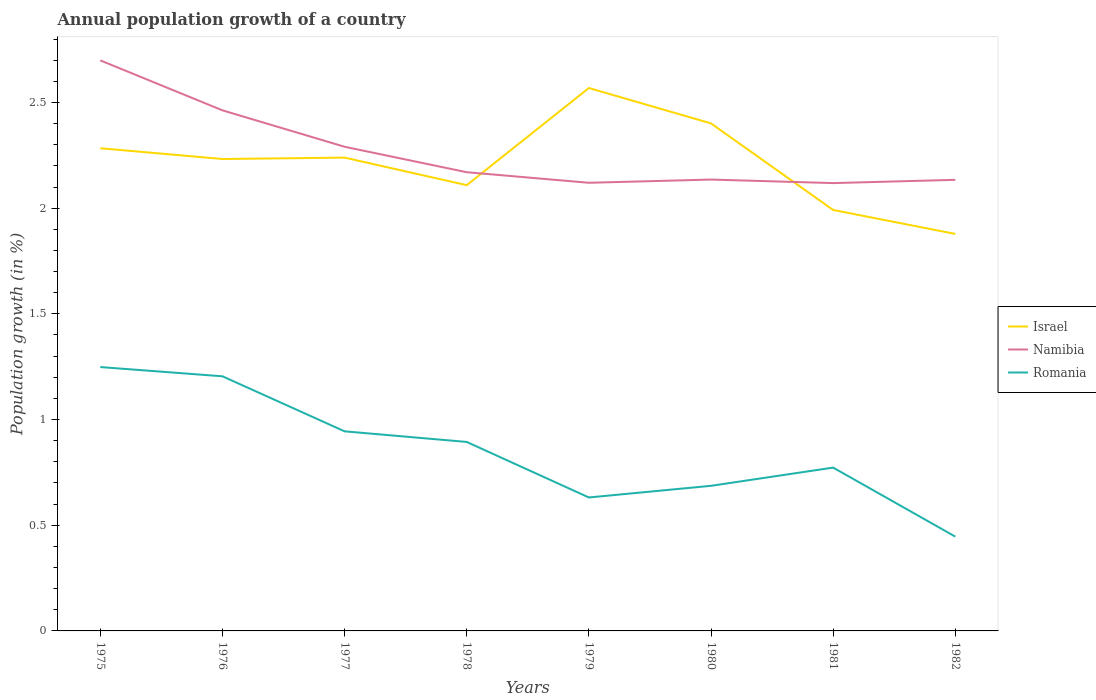Across all years, what is the maximum annual population growth in Namibia?
Your response must be concise. 2.12. What is the total annual population growth in Romania in the graph?
Offer a very short reply. 0.19. What is the difference between the highest and the second highest annual population growth in Israel?
Provide a short and direct response. 0.69. What is the difference between the highest and the lowest annual population growth in Israel?
Provide a succinct answer. 5. Is the annual population growth in Namibia strictly greater than the annual population growth in Romania over the years?
Make the answer very short. No. How many years are there in the graph?
Provide a succinct answer. 8. What is the difference between two consecutive major ticks on the Y-axis?
Keep it short and to the point. 0.5. Does the graph contain any zero values?
Ensure brevity in your answer.  No. Does the graph contain grids?
Keep it short and to the point. No. Where does the legend appear in the graph?
Your answer should be very brief. Center right. How many legend labels are there?
Your response must be concise. 3. What is the title of the graph?
Your answer should be very brief. Annual population growth of a country. What is the label or title of the Y-axis?
Make the answer very short. Population growth (in %). What is the Population growth (in %) in Israel in 1975?
Your answer should be compact. 2.28. What is the Population growth (in %) in Namibia in 1975?
Give a very brief answer. 2.7. What is the Population growth (in %) of Romania in 1975?
Offer a very short reply. 1.25. What is the Population growth (in %) of Israel in 1976?
Your answer should be very brief. 2.23. What is the Population growth (in %) of Namibia in 1976?
Provide a short and direct response. 2.46. What is the Population growth (in %) in Romania in 1976?
Your answer should be very brief. 1.2. What is the Population growth (in %) in Israel in 1977?
Keep it short and to the point. 2.24. What is the Population growth (in %) of Namibia in 1977?
Offer a very short reply. 2.29. What is the Population growth (in %) in Romania in 1977?
Make the answer very short. 0.94. What is the Population growth (in %) of Israel in 1978?
Your answer should be compact. 2.11. What is the Population growth (in %) of Namibia in 1978?
Ensure brevity in your answer.  2.17. What is the Population growth (in %) in Romania in 1978?
Give a very brief answer. 0.89. What is the Population growth (in %) in Israel in 1979?
Give a very brief answer. 2.57. What is the Population growth (in %) in Namibia in 1979?
Ensure brevity in your answer.  2.12. What is the Population growth (in %) in Romania in 1979?
Offer a very short reply. 0.63. What is the Population growth (in %) in Israel in 1980?
Your answer should be very brief. 2.4. What is the Population growth (in %) in Namibia in 1980?
Provide a short and direct response. 2.14. What is the Population growth (in %) in Romania in 1980?
Offer a very short reply. 0.69. What is the Population growth (in %) of Israel in 1981?
Ensure brevity in your answer.  1.99. What is the Population growth (in %) in Namibia in 1981?
Your answer should be very brief. 2.12. What is the Population growth (in %) in Romania in 1981?
Offer a terse response. 0.77. What is the Population growth (in %) of Israel in 1982?
Your answer should be very brief. 1.88. What is the Population growth (in %) in Namibia in 1982?
Offer a terse response. 2.13. What is the Population growth (in %) of Romania in 1982?
Offer a terse response. 0.45. Across all years, what is the maximum Population growth (in %) in Israel?
Your answer should be very brief. 2.57. Across all years, what is the maximum Population growth (in %) in Namibia?
Keep it short and to the point. 2.7. Across all years, what is the maximum Population growth (in %) of Romania?
Offer a very short reply. 1.25. Across all years, what is the minimum Population growth (in %) in Israel?
Your answer should be very brief. 1.88. Across all years, what is the minimum Population growth (in %) of Namibia?
Your answer should be compact. 2.12. Across all years, what is the minimum Population growth (in %) of Romania?
Offer a terse response. 0.45. What is the total Population growth (in %) of Israel in the graph?
Ensure brevity in your answer.  17.7. What is the total Population growth (in %) in Namibia in the graph?
Ensure brevity in your answer.  18.13. What is the total Population growth (in %) of Romania in the graph?
Give a very brief answer. 6.83. What is the difference between the Population growth (in %) in Israel in 1975 and that in 1976?
Make the answer very short. 0.05. What is the difference between the Population growth (in %) of Namibia in 1975 and that in 1976?
Provide a succinct answer. 0.24. What is the difference between the Population growth (in %) in Romania in 1975 and that in 1976?
Your answer should be compact. 0.04. What is the difference between the Population growth (in %) in Israel in 1975 and that in 1977?
Your answer should be very brief. 0.04. What is the difference between the Population growth (in %) in Namibia in 1975 and that in 1977?
Provide a succinct answer. 0.41. What is the difference between the Population growth (in %) of Romania in 1975 and that in 1977?
Your response must be concise. 0.3. What is the difference between the Population growth (in %) of Israel in 1975 and that in 1978?
Provide a succinct answer. 0.17. What is the difference between the Population growth (in %) of Namibia in 1975 and that in 1978?
Your answer should be very brief. 0.53. What is the difference between the Population growth (in %) of Romania in 1975 and that in 1978?
Your answer should be compact. 0.35. What is the difference between the Population growth (in %) in Israel in 1975 and that in 1979?
Keep it short and to the point. -0.28. What is the difference between the Population growth (in %) in Namibia in 1975 and that in 1979?
Offer a terse response. 0.58. What is the difference between the Population growth (in %) in Romania in 1975 and that in 1979?
Ensure brevity in your answer.  0.62. What is the difference between the Population growth (in %) of Israel in 1975 and that in 1980?
Your answer should be compact. -0.12. What is the difference between the Population growth (in %) of Namibia in 1975 and that in 1980?
Your answer should be compact. 0.56. What is the difference between the Population growth (in %) of Romania in 1975 and that in 1980?
Provide a succinct answer. 0.56. What is the difference between the Population growth (in %) in Israel in 1975 and that in 1981?
Give a very brief answer. 0.29. What is the difference between the Population growth (in %) in Namibia in 1975 and that in 1981?
Your answer should be compact. 0.58. What is the difference between the Population growth (in %) in Romania in 1975 and that in 1981?
Offer a terse response. 0.48. What is the difference between the Population growth (in %) of Israel in 1975 and that in 1982?
Make the answer very short. 0.41. What is the difference between the Population growth (in %) in Namibia in 1975 and that in 1982?
Provide a succinct answer. 0.57. What is the difference between the Population growth (in %) of Romania in 1975 and that in 1982?
Ensure brevity in your answer.  0.8. What is the difference between the Population growth (in %) of Israel in 1976 and that in 1977?
Your answer should be compact. -0.01. What is the difference between the Population growth (in %) in Namibia in 1976 and that in 1977?
Keep it short and to the point. 0.17. What is the difference between the Population growth (in %) in Romania in 1976 and that in 1977?
Provide a succinct answer. 0.26. What is the difference between the Population growth (in %) of Israel in 1976 and that in 1978?
Offer a terse response. 0.12. What is the difference between the Population growth (in %) of Namibia in 1976 and that in 1978?
Provide a short and direct response. 0.29. What is the difference between the Population growth (in %) in Romania in 1976 and that in 1978?
Provide a short and direct response. 0.31. What is the difference between the Population growth (in %) of Israel in 1976 and that in 1979?
Offer a very short reply. -0.34. What is the difference between the Population growth (in %) of Namibia in 1976 and that in 1979?
Keep it short and to the point. 0.34. What is the difference between the Population growth (in %) of Romania in 1976 and that in 1979?
Make the answer very short. 0.57. What is the difference between the Population growth (in %) in Israel in 1976 and that in 1980?
Make the answer very short. -0.17. What is the difference between the Population growth (in %) in Namibia in 1976 and that in 1980?
Give a very brief answer. 0.33. What is the difference between the Population growth (in %) of Romania in 1976 and that in 1980?
Your answer should be very brief. 0.52. What is the difference between the Population growth (in %) in Israel in 1976 and that in 1981?
Offer a very short reply. 0.24. What is the difference between the Population growth (in %) in Namibia in 1976 and that in 1981?
Your response must be concise. 0.34. What is the difference between the Population growth (in %) of Romania in 1976 and that in 1981?
Ensure brevity in your answer.  0.43. What is the difference between the Population growth (in %) in Israel in 1976 and that in 1982?
Make the answer very short. 0.35. What is the difference between the Population growth (in %) in Namibia in 1976 and that in 1982?
Your response must be concise. 0.33. What is the difference between the Population growth (in %) of Romania in 1976 and that in 1982?
Your answer should be very brief. 0.76. What is the difference between the Population growth (in %) in Israel in 1977 and that in 1978?
Provide a short and direct response. 0.13. What is the difference between the Population growth (in %) in Namibia in 1977 and that in 1978?
Offer a very short reply. 0.12. What is the difference between the Population growth (in %) in Romania in 1977 and that in 1978?
Keep it short and to the point. 0.05. What is the difference between the Population growth (in %) of Israel in 1977 and that in 1979?
Provide a succinct answer. -0.33. What is the difference between the Population growth (in %) in Namibia in 1977 and that in 1979?
Your answer should be very brief. 0.17. What is the difference between the Population growth (in %) of Romania in 1977 and that in 1979?
Provide a short and direct response. 0.31. What is the difference between the Population growth (in %) of Israel in 1977 and that in 1980?
Your answer should be compact. -0.16. What is the difference between the Population growth (in %) in Namibia in 1977 and that in 1980?
Give a very brief answer. 0.16. What is the difference between the Population growth (in %) in Romania in 1977 and that in 1980?
Provide a succinct answer. 0.26. What is the difference between the Population growth (in %) in Israel in 1977 and that in 1981?
Ensure brevity in your answer.  0.25. What is the difference between the Population growth (in %) in Namibia in 1977 and that in 1981?
Offer a terse response. 0.17. What is the difference between the Population growth (in %) of Romania in 1977 and that in 1981?
Offer a very short reply. 0.17. What is the difference between the Population growth (in %) in Israel in 1977 and that in 1982?
Offer a terse response. 0.36. What is the difference between the Population growth (in %) of Namibia in 1977 and that in 1982?
Provide a succinct answer. 0.16. What is the difference between the Population growth (in %) of Romania in 1977 and that in 1982?
Your answer should be compact. 0.5. What is the difference between the Population growth (in %) of Israel in 1978 and that in 1979?
Give a very brief answer. -0.46. What is the difference between the Population growth (in %) of Romania in 1978 and that in 1979?
Provide a succinct answer. 0.26. What is the difference between the Population growth (in %) in Israel in 1978 and that in 1980?
Provide a short and direct response. -0.29. What is the difference between the Population growth (in %) in Namibia in 1978 and that in 1980?
Offer a terse response. 0.03. What is the difference between the Population growth (in %) in Romania in 1978 and that in 1980?
Your answer should be compact. 0.21. What is the difference between the Population growth (in %) in Israel in 1978 and that in 1981?
Your answer should be compact. 0.12. What is the difference between the Population growth (in %) of Namibia in 1978 and that in 1981?
Give a very brief answer. 0.05. What is the difference between the Population growth (in %) of Romania in 1978 and that in 1981?
Your response must be concise. 0.12. What is the difference between the Population growth (in %) in Israel in 1978 and that in 1982?
Make the answer very short. 0.23. What is the difference between the Population growth (in %) in Namibia in 1978 and that in 1982?
Your response must be concise. 0.04. What is the difference between the Population growth (in %) in Romania in 1978 and that in 1982?
Provide a succinct answer. 0.45. What is the difference between the Population growth (in %) in Israel in 1979 and that in 1980?
Keep it short and to the point. 0.17. What is the difference between the Population growth (in %) in Namibia in 1979 and that in 1980?
Provide a short and direct response. -0.02. What is the difference between the Population growth (in %) in Romania in 1979 and that in 1980?
Make the answer very short. -0.06. What is the difference between the Population growth (in %) in Israel in 1979 and that in 1981?
Provide a short and direct response. 0.58. What is the difference between the Population growth (in %) of Namibia in 1979 and that in 1981?
Your answer should be very brief. 0. What is the difference between the Population growth (in %) of Romania in 1979 and that in 1981?
Make the answer very short. -0.14. What is the difference between the Population growth (in %) in Israel in 1979 and that in 1982?
Provide a short and direct response. 0.69. What is the difference between the Population growth (in %) of Namibia in 1979 and that in 1982?
Your answer should be very brief. -0.01. What is the difference between the Population growth (in %) of Romania in 1979 and that in 1982?
Offer a very short reply. 0.19. What is the difference between the Population growth (in %) in Israel in 1980 and that in 1981?
Offer a very short reply. 0.41. What is the difference between the Population growth (in %) in Namibia in 1980 and that in 1981?
Your answer should be compact. 0.02. What is the difference between the Population growth (in %) in Romania in 1980 and that in 1981?
Your response must be concise. -0.09. What is the difference between the Population growth (in %) of Israel in 1980 and that in 1982?
Provide a short and direct response. 0.52. What is the difference between the Population growth (in %) of Namibia in 1980 and that in 1982?
Provide a succinct answer. 0. What is the difference between the Population growth (in %) of Romania in 1980 and that in 1982?
Give a very brief answer. 0.24. What is the difference between the Population growth (in %) in Israel in 1981 and that in 1982?
Provide a short and direct response. 0.11. What is the difference between the Population growth (in %) in Namibia in 1981 and that in 1982?
Provide a succinct answer. -0.02. What is the difference between the Population growth (in %) in Romania in 1981 and that in 1982?
Provide a succinct answer. 0.33. What is the difference between the Population growth (in %) of Israel in 1975 and the Population growth (in %) of Namibia in 1976?
Offer a terse response. -0.18. What is the difference between the Population growth (in %) in Israel in 1975 and the Population growth (in %) in Romania in 1976?
Keep it short and to the point. 1.08. What is the difference between the Population growth (in %) of Namibia in 1975 and the Population growth (in %) of Romania in 1976?
Provide a short and direct response. 1.49. What is the difference between the Population growth (in %) of Israel in 1975 and the Population growth (in %) of Namibia in 1977?
Your response must be concise. -0.01. What is the difference between the Population growth (in %) in Israel in 1975 and the Population growth (in %) in Romania in 1977?
Offer a terse response. 1.34. What is the difference between the Population growth (in %) of Namibia in 1975 and the Population growth (in %) of Romania in 1977?
Your answer should be very brief. 1.75. What is the difference between the Population growth (in %) of Israel in 1975 and the Population growth (in %) of Namibia in 1978?
Offer a very short reply. 0.11. What is the difference between the Population growth (in %) in Israel in 1975 and the Population growth (in %) in Romania in 1978?
Give a very brief answer. 1.39. What is the difference between the Population growth (in %) in Namibia in 1975 and the Population growth (in %) in Romania in 1978?
Ensure brevity in your answer.  1.81. What is the difference between the Population growth (in %) of Israel in 1975 and the Population growth (in %) of Namibia in 1979?
Make the answer very short. 0.16. What is the difference between the Population growth (in %) in Israel in 1975 and the Population growth (in %) in Romania in 1979?
Your answer should be compact. 1.65. What is the difference between the Population growth (in %) in Namibia in 1975 and the Population growth (in %) in Romania in 1979?
Keep it short and to the point. 2.07. What is the difference between the Population growth (in %) of Israel in 1975 and the Population growth (in %) of Namibia in 1980?
Your answer should be very brief. 0.15. What is the difference between the Population growth (in %) of Israel in 1975 and the Population growth (in %) of Romania in 1980?
Offer a terse response. 1.6. What is the difference between the Population growth (in %) of Namibia in 1975 and the Population growth (in %) of Romania in 1980?
Provide a succinct answer. 2.01. What is the difference between the Population growth (in %) in Israel in 1975 and the Population growth (in %) in Namibia in 1981?
Provide a succinct answer. 0.16. What is the difference between the Population growth (in %) in Israel in 1975 and the Population growth (in %) in Romania in 1981?
Your answer should be very brief. 1.51. What is the difference between the Population growth (in %) of Namibia in 1975 and the Population growth (in %) of Romania in 1981?
Provide a succinct answer. 1.93. What is the difference between the Population growth (in %) in Israel in 1975 and the Population growth (in %) in Namibia in 1982?
Give a very brief answer. 0.15. What is the difference between the Population growth (in %) in Israel in 1975 and the Population growth (in %) in Romania in 1982?
Give a very brief answer. 1.84. What is the difference between the Population growth (in %) of Namibia in 1975 and the Population growth (in %) of Romania in 1982?
Your answer should be very brief. 2.25. What is the difference between the Population growth (in %) of Israel in 1976 and the Population growth (in %) of Namibia in 1977?
Your answer should be compact. -0.06. What is the difference between the Population growth (in %) of Israel in 1976 and the Population growth (in %) of Romania in 1977?
Ensure brevity in your answer.  1.29. What is the difference between the Population growth (in %) of Namibia in 1976 and the Population growth (in %) of Romania in 1977?
Keep it short and to the point. 1.52. What is the difference between the Population growth (in %) of Israel in 1976 and the Population growth (in %) of Namibia in 1978?
Offer a very short reply. 0.06. What is the difference between the Population growth (in %) in Israel in 1976 and the Population growth (in %) in Romania in 1978?
Offer a terse response. 1.34. What is the difference between the Population growth (in %) of Namibia in 1976 and the Population growth (in %) of Romania in 1978?
Your answer should be very brief. 1.57. What is the difference between the Population growth (in %) in Israel in 1976 and the Population growth (in %) in Namibia in 1979?
Keep it short and to the point. 0.11. What is the difference between the Population growth (in %) in Israel in 1976 and the Population growth (in %) in Romania in 1979?
Make the answer very short. 1.6. What is the difference between the Population growth (in %) of Namibia in 1976 and the Population growth (in %) of Romania in 1979?
Your response must be concise. 1.83. What is the difference between the Population growth (in %) in Israel in 1976 and the Population growth (in %) in Namibia in 1980?
Give a very brief answer. 0.1. What is the difference between the Population growth (in %) of Israel in 1976 and the Population growth (in %) of Romania in 1980?
Make the answer very short. 1.55. What is the difference between the Population growth (in %) of Namibia in 1976 and the Population growth (in %) of Romania in 1980?
Make the answer very short. 1.78. What is the difference between the Population growth (in %) of Israel in 1976 and the Population growth (in %) of Namibia in 1981?
Offer a terse response. 0.11. What is the difference between the Population growth (in %) in Israel in 1976 and the Population growth (in %) in Romania in 1981?
Your answer should be very brief. 1.46. What is the difference between the Population growth (in %) of Namibia in 1976 and the Population growth (in %) of Romania in 1981?
Offer a terse response. 1.69. What is the difference between the Population growth (in %) in Israel in 1976 and the Population growth (in %) in Namibia in 1982?
Provide a succinct answer. 0.1. What is the difference between the Population growth (in %) in Israel in 1976 and the Population growth (in %) in Romania in 1982?
Make the answer very short. 1.79. What is the difference between the Population growth (in %) in Namibia in 1976 and the Population growth (in %) in Romania in 1982?
Your answer should be compact. 2.02. What is the difference between the Population growth (in %) of Israel in 1977 and the Population growth (in %) of Namibia in 1978?
Your answer should be compact. 0.07. What is the difference between the Population growth (in %) in Israel in 1977 and the Population growth (in %) in Romania in 1978?
Offer a very short reply. 1.35. What is the difference between the Population growth (in %) in Namibia in 1977 and the Population growth (in %) in Romania in 1978?
Ensure brevity in your answer.  1.4. What is the difference between the Population growth (in %) of Israel in 1977 and the Population growth (in %) of Namibia in 1979?
Make the answer very short. 0.12. What is the difference between the Population growth (in %) of Israel in 1977 and the Population growth (in %) of Romania in 1979?
Offer a very short reply. 1.61. What is the difference between the Population growth (in %) of Namibia in 1977 and the Population growth (in %) of Romania in 1979?
Make the answer very short. 1.66. What is the difference between the Population growth (in %) of Israel in 1977 and the Population growth (in %) of Namibia in 1980?
Provide a short and direct response. 0.1. What is the difference between the Population growth (in %) in Israel in 1977 and the Population growth (in %) in Romania in 1980?
Offer a very short reply. 1.55. What is the difference between the Population growth (in %) of Namibia in 1977 and the Population growth (in %) of Romania in 1980?
Your answer should be compact. 1.6. What is the difference between the Population growth (in %) of Israel in 1977 and the Population growth (in %) of Namibia in 1981?
Your answer should be very brief. 0.12. What is the difference between the Population growth (in %) of Israel in 1977 and the Population growth (in %) of Romania in 1981?
Keep it short and to the point. 1.47. What is the difference between the Population growth (in %) of Namibia in 1977 and the Population growth (in %) of Romania in 1981?
Your response must be concise. 1.52. What is the difference between the Population growth (in %) in Israel in 1977 and the Population growth (in %) in Namibia in 1982?
Your answer should be very brief. 0.11. What is the difference between the Population growth (in %) in Israel in 1977 and the Population growth (in %) in Romania in 1982?
Offer a terse response. 1.79. What is the difference between the Population growth (in %) in Namibia in 1977 and the Population growth (in %) in Romania in 1982?
Keep it short and to the point. 1.84. What is the difference between the Population growth (in %) in Israel in 1978 and the Population growth (in %) in Namibia in 1979?
Make the answer very short. -0.01. What is the difference between the Population growth (in %) of Israel in 1978 and the Population growth (in %) of Romania in 1979?
Provide a short and direct response. 1.48. What is the difference between the Population growth (in %) of Namibia in 1978 and the Population growth (in %) of Romania in 1979?
Ensure brevity in your answer.  1.54. What is the difference between the Population growth (in %) in Israel in 1978 and the Population growth (in %) in Namibia in 1980?
Provide a succinct answer. -0.03. What is the difference between the Population growth (in %) in Israel in 1978 and the Population growth (in %) in Romania in 1980?
Ensure brevity in your answer.  1.42. What is the difference between the Population growth (in %) in Namibia in 1978 and the Population growth (in %) in Romania in 1980?
Make the answer very short. 1.48. What is the difference between the Population growth (in %) in Israel in 1978 and the Population growth (in %) in Namibia in 1981?
Ensure brevity in your answer.  -0.01. What is the difference between the Population growth (in %) in Israel in 1978 and the Population growth (in %) in Romania in 1981?
Make the answer very short. 1.34. What is the difference between the Population growth (in %) in Namibia in 1978 and the Population growth (in %) in Romania in 1981?
Keep it short and to the point. 1.4. What is the difference between the Population growth (in %) in Israel in 1978 and the Population growth (in %) in Namibia in 1982?
Give a very brief answer. -0.03. What is the difference between the Population growth (in %) of Israel in 1978 and the Population growth (in %) of Romania in 1982?
Offer a very short reply. 1.66. What is the difference between the Population growth (in %) in Namibia in 1978 and the Population growth (in %) in Romania in 1982?
Keep it short and to the point. 1.72. What is the difference between the Population growth (in %) in Israel in 1979 and the Population growth (in %) in Namibia in 1980?
Your response must be concise. 0.43. What is the difference between the Population growth (in %) of Israel in 1979 and the Population growth (in %) of Romania in 1980?
Make the answer very short. 1.88. What is the difference between the Population growth (in %) of Namibia in 1979 and the Population growth (in %) of Romania in 1980?
Offer a terse response. 1.43. What is the difference between the Population growth (in %) of Israel in 1979 and the Population growth (in %) of Namibia in 1981?
Offer a terse response. 0.45. What is the difference between the Population growth (in %) of Israel in 1979 and the Population growth (in %) of Romania in 1981?
Keep it short and to the point. 1.8. What is the difference between the Population growth (in %) in Namibia in 1979 and the Population growth (in %) in Romania in 1981?
Your answer should be very brief. 1.35. What is the difference between the Population growth (in %) of Israel in 1979 and the Population growth (in %) of Namibia in 1982?
Ensure brevity in your answer.  0.43. What is the difference between the Population growth (in %) in Israel in 1979 and the Population growth (in %) in Romania in 1982?
Offer a terse response. 2.12. What is the difference between the Population growth (in %) in Namibia in 1979 and the Population growth (in %) in Romania in 1982?
Give a very brief answer. 1.67. What is the difference between the Population growth (in %) in Israel in 1980 and the Population growth (in %) in Namibia in 1981?
Your response must be concise. 0.28. What is the difference between the Population growth (in %) in Israel in 1980 and the Population growth (in %) in Romania in 1981?
Provide a short and direct response. 1.63. What is the difference between the Population growth (in %) of Namibia in 1980 and the Population growth (in %) of Romania in 1981?
Offer a very short reply. 1.36. What is the difference between the Population growth (in %) in Israel in 1980 and the Population growth (in %) in Namibia in 1982?
Your answer should be very brief. 0.27. What is the difference between the Population growth (in %) of Israel in 1980 and the Population growth (in %) of Romania in 1982?
Offer a very short reply. 1.95. What is the difference between the Population growth (in %) of Namibia in 1980 and the Population growth (in %) of Romania in 1982?
Ensure brevity in your answer.  1.69. What is the difference between the Population growth (in %) in Israel in 1981 and the Population growth (in %) in Namibia in 1982?
Provide a succinct answer. -0.14. What is the difference between the Population growth (in %) in Israel in 1981 and the Population growth (in %) in Romania in 1982?
Make the answer very short. 1.55. What is the difference between the Population growth (in %) in Namibia in 1981 and the Population growth (in %) in Romania in 1982?
Keep it short and to the point. 1.67. What is the average Population growth (in %) of Israel per year?
Ensure brevity in your answer.  2.21. What is the average Population growth (in %) of Namibia per year?
Provide a succinct answer. 2.27. What is the average Population growth (in %) in Romania per year?
Your response must be concise. 0.85. In the year 1975, what is the difference between the Population growth (in %) in Israel and Population growth (in %) in Namibia?
Make the answer very short. -0.42. In the year 1975, what is the difference between the Population growth (in %) in Israel and Population growth (in %) in Romania?
Provide a succinct answer. 1.04. In the year 1975, what is the difference between the Population growth (in %) of Namibia and Population growth (in %) of Romania?
Provide a short and direct response. 1.45. In the year 1976, what is the difference between the Population growth (in %) in Israel and Population growth (in %) in Namibia?
Give a very brief answer. -0.23. In the year 1976, what is the difference between the Population growth (in %) of Israel and Population growth (in %) of Romania?
Offer a terse response. 1.03. In the year 1976, what is the difference between the Population growth (in %) in Namibia and Population growth (in %) in Romania?
Your answer should be compact. 1.26. In the year 1977, what is the difference between the Population growth (in %) of Israel and Population growth (in %) of Namibia?
Provide a short and direct response. -0.05. In the year 1977, what is the difference between the Population growth (in %) in Israel and Population growth (in %) in Romania?
Provide a short and direct response. 1.29. In the year 1977, what is the difference between the Population growth (in %) in Namibia and Population growth (in %) in Romania?
Give a very brief answer. 1.35. In the year 1978, what is the difference between the Population growth (in %) in Israel and Population growth (in %) in Namibia?
Keep it short and to the point. -0.06. In the year 1978, what is the difference between the Population growth (in %) in Israel and Population growth (in %) in Romania?
Provide a succinct answer. 1.21. In the year 1978, what is the difference between the Population growth (in %) in Namibia and Population growth (in %) in Romania?
Provide a short and direct response. 1.28. In the year 1979, what is the difference between the Population growth (in %) in Israel and Population growth (in %) in Namibia?
Your response must be concise. 0.45. In the year 1979, what is the difference between the Population growth (in %) of Israel and Population growth (in %) of Romania?
Provide a short and direct response. 1.94. In the year 1979, what is the difference between the Population growth (in %) in Namibia and Population growth (in %) in Romania?
Your answer should be very brief. 1.49. In the year 1980, what is the difference between the Population growth (in %) in Israel and Population growth (in %) in Namibia?
Provide a succinct answer. 0.27. In the year 1980, what is the difference between the Population growth (in %) of Israel and Population growth (in %) of Romania?
Your response must be concise. 1.71. In the year 1980, what is the difference between the Population growth (in %) in Namibia and Population growth (in %) in Romania?
Your answer should be very brief. 1.45. In the year 1981, what is the difference between the Population growth (in %) of Israel and Population growth (in %) of Namibia?
Offer a very short reply. -0.13. In the year 1981, what is the difference between the Population growth (in %) of Israel and Population growth (in %) of Romania?
Your answer should be very brief. 1.22. In the year 1981, what is the difference between the Population growth (in %) in Namibia and Population growth (in %) in Romania?
Your answer should be very brief. 1.35. In the year 1982, what is the difference between the Population growth (in %) in Israel and Population growth (in %) in Namibia?
Your response must be concise. -0.26. In the year 1982, what is the difference between the Population growth (in %) of Israel and Population growth (in %) of Romania?
Make the answer very short. 1.43. In the year 1982, what is the difference between the Population growth (in %) of Namibia and Population growth (in %) of Romania?
Provide a short and direct response. 1.69. What is the ratio of the Population growth (in %) in Israel in 1975 to that in 1976?
Your answer should be very brief. 1.02. What is the ratio of the Population growth (in %) in Namibia in 1975 to that in 1976?
Make the answer very short. 1.1. What is the ratio of the Population growth (in %) of Romania in 1975 to that in 1976?
Offer a very short reply. 1.04. What is the ratio of the Population growth (in %) in Israel in 1975 to that in 1977?
Provide a short and direct response. 1.02. What is the ratio of the Population growth (in %) of Namibia in 1975 to that in 1977?
Give a very brief answer. 1.18. What is the ratio of the Population growth (in %) in Romania in 1975 to that in 1977?
Provide a short and direct response. 1.32. What is the ratio of the Population growth (in %) in Israel in 1975 to that in 1978?
Your answer should be compact. 1.08. What is the ratio of the Population growth (in %) of Namibia in 1975 to that in 1978?
Make the answer very short. 1.24. What is the ratio of the Population growth (in %) of Romania in 1975 to that in 1978?
Your answer should be very brief. 1.4. What is the ratio of the Population growth (in %) in Israel in 1975 to that in 1979?
Ensure brevity in your answer.  0.89. What is the ratio of the Population growth (in %) of Namibia in 1975 to that in 1979?
Your answer should be very brief. 1.27. What is the ratio of the Population growth (in %) of Romania in 1975 to that in 1979?
Make the answer very short. 1.98. What is the ratio of the Population growth (in %) in Israel in 1975 to that in 1980?
Your response must be concise. 0.95. What is the ratio of the Population growth (in %) in Namibia in 1975 to that in 1980?
Ensure brevity in your answer.  1.26. What is the ratio of the Population growth (in %) in Romania in 1975 to that in 1980?
Give a very brief answer. 1.82. What is the ratio of the Population growth (in %) of Israel in 1975 to that in 1981?
Your answer should be very brief. 1.15. What is the ratio of the Population growth (in %) of Namibia in 1975 to that in 1981?
Your answer should be compact. 1.27. What is the ratio of the Population growth (in %) in Romania in 1975 to that in 1981?
Offer a very short reply. 1.62. What is the ratio of the Population growth (in %) in Israel in 1975 to that in 1982?
Offer a very short reply. 1.22. What is the ratio of the Population growth (in %) in Namibia in 1975 to that in 1982?
Offer a very short reply. 1.26. What is the ratio of the Population growth (in %) in Romania in 1975 to that in 1982?
Make the answer very short. 2.8. What is the ratio of the Population growth (in %) in Namibia in 1976 to that in 1977?
Ensure brevity in your answer.  1.08. What is the ratio of the Population growth (in %) in Romania in 1976 to that in 1977?
Your response must be concise. 1.28. What is the ratio of the Population growth (in %) of Israel in 1976 to that in 1978?
Provide a short and direct response. 1.06. What is the ratio of the Population growth (in %) in Namibia in 1976 to that in 1978?
Offer a terse response. 1.13. What is the ratio of the Population growth (in %) of Romania in 1976 to that in 1978?
Ensure brevity in your answer.  1.35. What is the ratio of the Population growth (in %) in Israel in 1976 to that in 1979?
Provide a succinct answer. 0.87. What is the ratio of the Population growth (in %) in Namibia in 1976 to that in 1979?
Provide a succinct answer. 1.16. What is the ratio of the Population growth (in %) in Romania in 1976 to that in 1979?
Provide a succinct answer. 1.91. What is the ratio of the Population growth (in %) of Israel in 1976 to that in 1980?
Provide a succinct answer. 0.93. What is the ratio of the Population growth (in %) in Namibia in 1976 to that in 1980?
Provide a short and direct response. 1.15. What is the ratio of the Population growth (in %) in Romania in 1976 to that in 1980?
Provide a short and direct response. 1.75. What is the ratio of the Population growth (in %) in Israel in 1976 to that in 1981?
Provide a short and direct response. 1.12. What is the ratio of the Population growth (in %) in Namibia in 1976 to that in 1981?
Provide a succinct answer. 1.16. What is the ratio of the Population growth (in %) in Romania in 1976 to that in 1981?
Your answer should be compact. 1.56. What is the ratio of the Population growth (in %) in Israel in 1976 to that in 1982?
Ensure brevity in your answer.  1.19. What is the ratio of the Population growth (in %) in Namibia in 1976 to that in 1982?
Your answer should be very brief. 1.15. What is the ratio of the Population growth (in %) in Romania in 1976 to that in 1982?
Offer a terse response. 2.7. What is the ratio of the Population growth (in %) in Israel in 1977 to that in 1978?
Keep it short and to the point. 1.06. What is the ratio of the Population growth (in %) of Namibia in 1977 to that in 1978?
Make the answer very short. 1.06. What is the ratio of the Population growth (in %) in Romania in 1977 to that in 1978?
Your answer should be very brief. 1.06. What is the ratio of the Population growth (in %) of Israel in 1977 to that in 1979?
Give a very brief answer. 0.87. What is the ratio of the Population growth (in %) of Namibia in 1977 to that in 1979?
Provide a succinct answer. 1.08. What is the ratio of the Population growth (in %) of Romania in 1977 to that in 1979?
Provide a short and direct response. 1.5. What is the ratio of the Population growth (in %) of Israel in 1977 to that in 1980?
Provide a short and direct response. 0.93. What is the ratio of the Population growth (in %) of Namibia in 1977 to that in 1980?
Keep it short and to the point. 1.07. What is the ratio of the Population growth (in %) of Romania in 1977 to that in 1980?
Your response must be concise. 1.38. What is the ratio of the Population growth (in %) in Israel in 1977 to that in 1981?
Keep it short and to the point. 1.12. What is the ratio of the Population growth (in %) in Namibia in 1977 to that in 1981?
Keep it short and to the point. 1.08. What is the ratio of the Population growth (in %) of Romania in 1977 to that in 1981?
Give a very brief answer. 1.22. What is the ratio of the Population growth (in %) of Israel in 1977 to that in 1982?
Make the answer very short. 1.19. What is the ratio of the Population growth (in %) of Namibia in 1977 to that in 1982?
Your answer should be compact. 1.07. What is the ratio of the Population growth (in %) in Romania in 1977 to that in 1982?
Ensure brevity in your answer.  2.12. What is the ratio of the Population growth (in %) in Israel in 1978 to that in 1979?
Provide a short and direct response. 0.82. What is the ratio of the Population growth (in %) in Namibia in 1978 to that in 1979?
Your answer should be very brief. 1.02. What is the ratio of the Population growth (in %) in Romania in 1978 to that in 1979?
Provide a short and direct response. 1.42. What is the ratio of the Population growth (in %) in Israel in 1978 to that in 1980?
Offer a very short reply. 0.88. What is the ratio of the Population growth (in %) of Namibia in 1978 to that in 1980?
Offer a terse response. 1.02. What is the ratio of the Population growth (in %) of Romania in 1978 to that in 1980?
Your response must be concise. 1.3. What is the ratio of the Population growth (in %) of Israel in 1978 to that in 1981?
Give a very brief answer. 1.06. What is the ratio of the Population growth (in %) of Namibia in 1978 to that in 1981?
Keep it short and to the point. 1.02. What is the ratio of the Population growth (in %) of Romania in 1978 to that in 1981?
Offer a very short reply. 1.16. What is the ratio of the Population growth (in %) in Israel in 1978 to that in 1982?
Make the answer very short. 1.12. What is the ratio of the Population growth (in %) of Namibia in 1978 to that in 1982?
Give a very brief answer. 1.02. What is the ratio of the Population growth (in %) in Romania in 1978 to that in 1982?
Provide a short and direct response. 2. What is the ratio of the Population growth (in %) of Israel in 1979 to that in 1980?
Your answer should be compact. 1.07. What is the ratio of the Population growth (in %) of Romania in 1979 to that in 1980?
Give a very brief answer. 0.92. What is the ratio of the Population growth (in %) in Israel in 1979 to that in 1981?
Keep it short and to the point. 1.29. What is the ratio of the Population growth (in %) in Romania in 1979 to that in 1981?
Give a very brief answer. 0.82. What is the ratio of the Population growth (in %) of Israel in 1979 to that in 1982?
Your answer should be very brief. 1.37. What is the ratio of the Population growth (in %) in Romania in 1979 to that in 1982?
Make the answer very short. 1.42. What is the ratio of the Population growth (in %) of Israel in 1980 to that in 1981?
Your answer should be compact. 1.21. What is the ratio of the Population growth (in %) in Namibia in 1980 to that in 1981?
Ensure brevity in your answer.  1.01. What is the ratio of the Population growth (in %) in Romania in 1980 to that in 1981?
Make the answer very short. 0.89. What is the ratio of the Population growth (in %) in Israel in 1980 to that in 1982?
Offer a very short reply. 1.28. What is the ratio of the Population growth (in %) of Namibia in 1980 to that in 1982?
Offer a terse response. 1. What is the ratio of the Population growth (in %) in Romania in 1980 to that in 1982?
Offer a very short reply. 1.54. What is the ratio of the Population growth (in %) of Israel in 1981 to that in 1982?
Your answer should be very brief. 1.06. What is the ratio of the Population growth (in %) in Romania in 1981 to that in 1982?
Make the answer very short. 1.73. What is the difference between the highest and the second highest Population growth (in %) in Israel?
Give a very brief answer. 0.17. What is the difference between the highest and the second highest Population growth (in %) of Namibia?
Provide a succinct answer. 0.24. What is the difference between the highest and the second highest Population growth (in %) in Romania?
Ensure brevity in your answer.  0.04. What is the difference between the highest and the lowest Population growth (in %) in Israel?
Your response must be concise. 0.69. What is the difference between the highest and the lowest Population growth (in %) of Namibia?
Ensure brevity in your answer.  0.58. What is the difference between the highest and the lowest Population growth (in %) in Romania?
Provide a succinct answer. 0.8. 